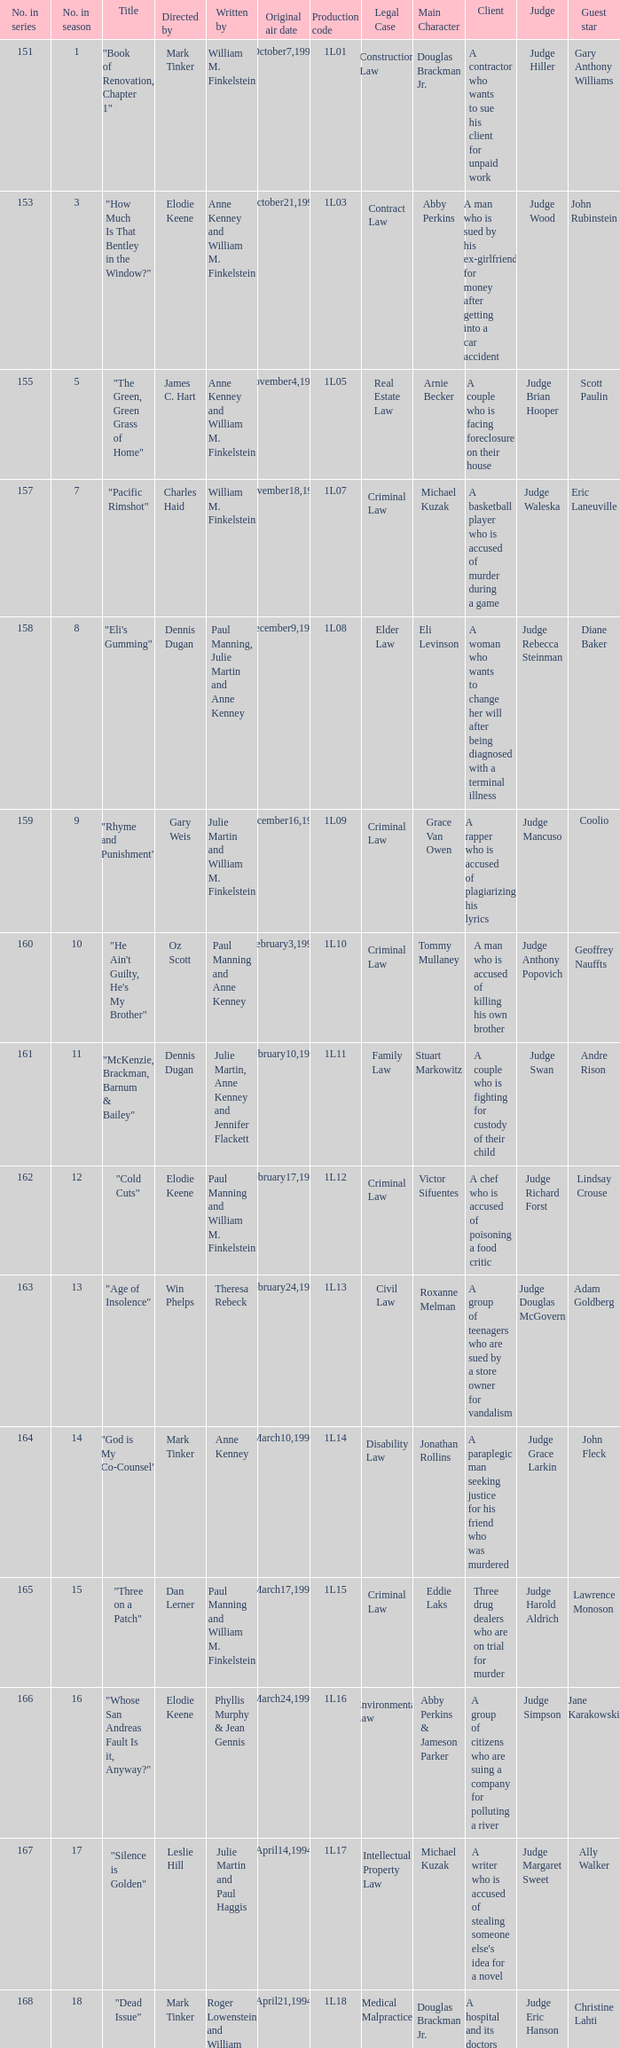Name the most number in season for leslie hill 17.0. 